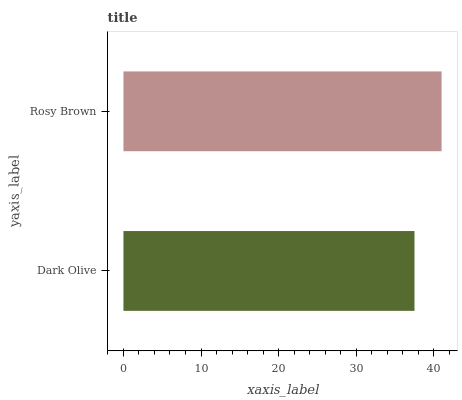Is Dark Olive the minimum?
Answer yes or no. Yes. Is Rosy Brown the maximum?
Answer yes or no. Yes. Is Rosy Brown the minimum?
Answer yes or no. No. Is Rosy Brown greater than Dark Olive?
Answer yes or no. Yes. Is Dark Olive less than Rosy Brown?
Answer yes or no. Yes. Is Dark Olive greater than Rosy Brown?
Answer yes or no. No. Is Rosy Brown less than Dark Olive?
Answer yes or no. No. Is Rosy Brown the high median?
Answer yes or no. Yes. Is Dark Olive the low median?
Answer yes or no. Yes. Is Dark Olive the high median?
Answer yes or no. No. Is Rosy Brown the low median?
Answer yes or no. No. 